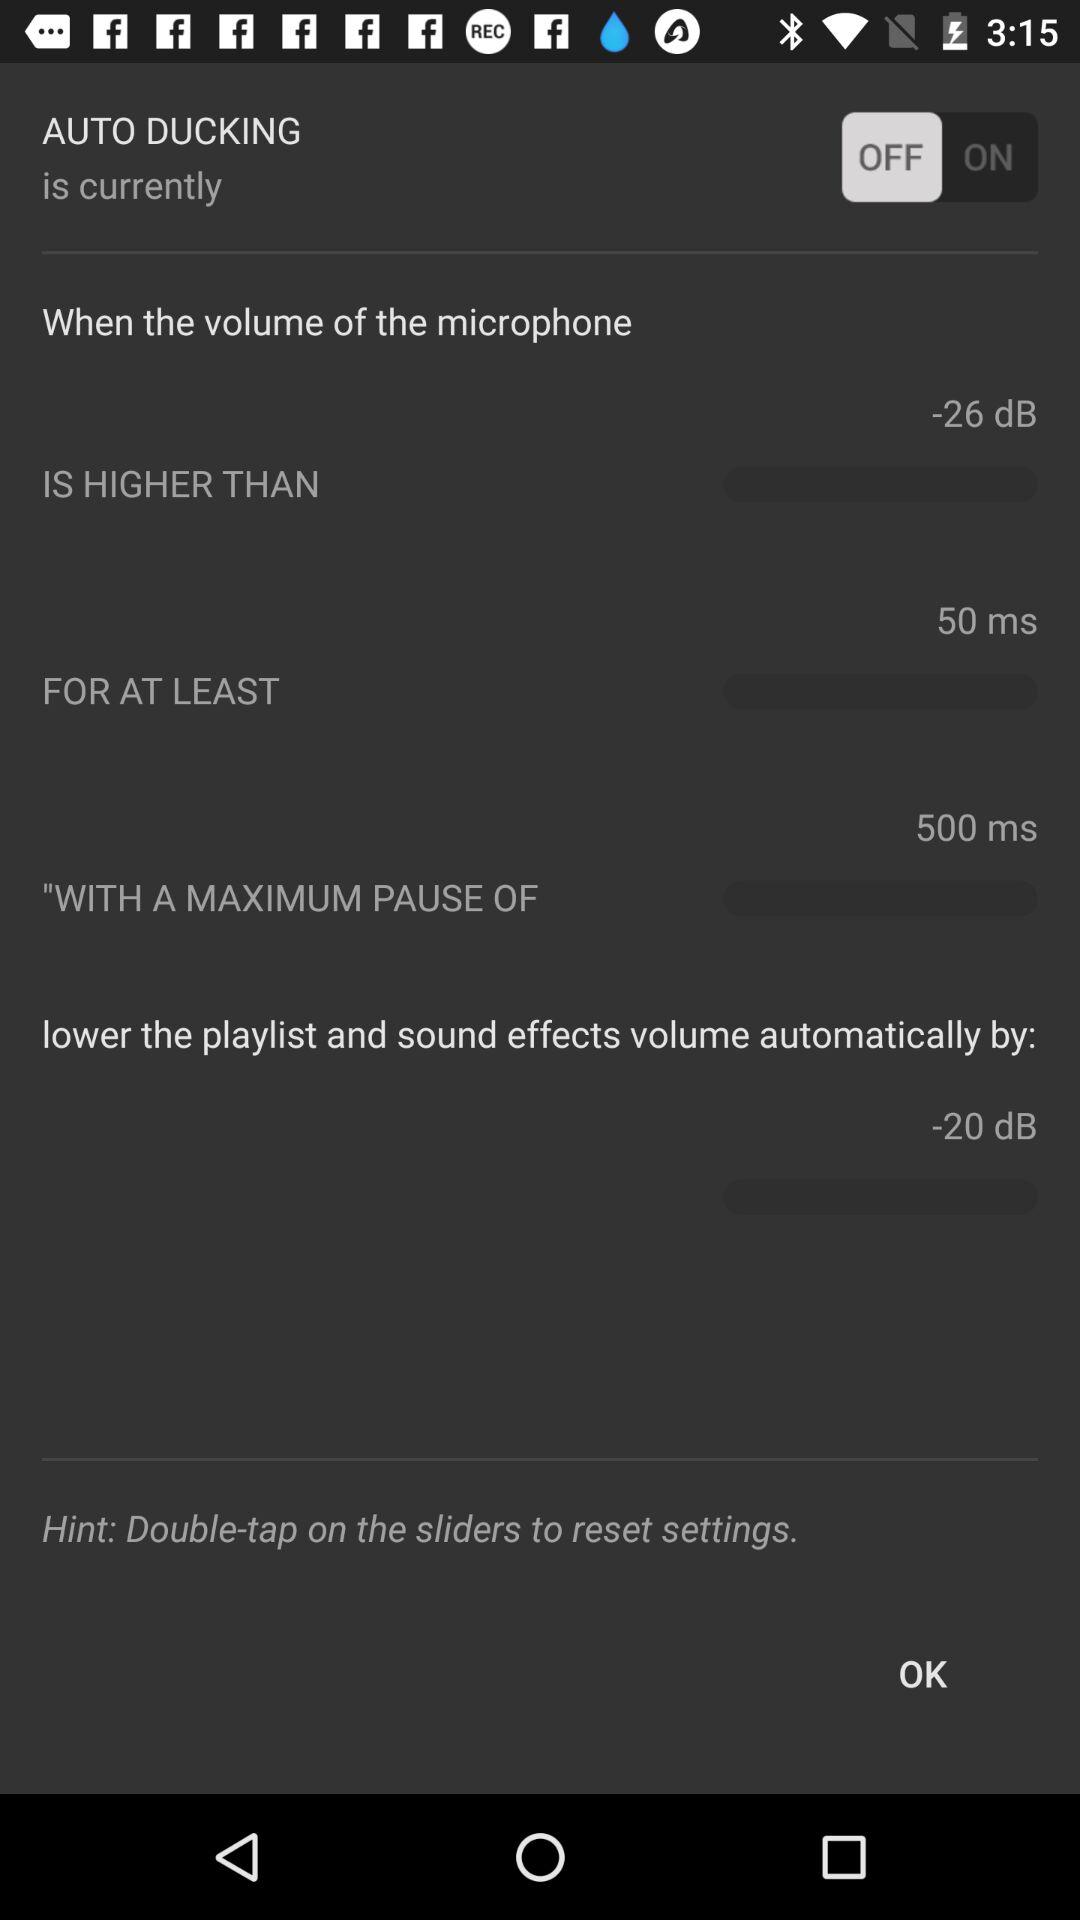What is the status of "AUTO DUCKING"? The status is "off". 